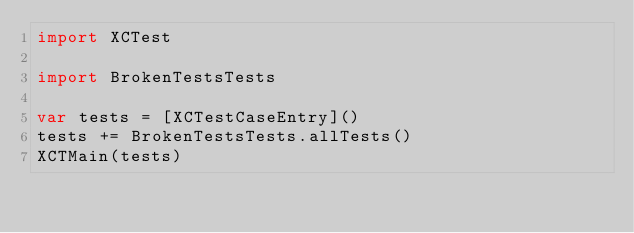Convert code to text. <code><loc_0><loc_0><loc_500><loc_500><_Swift_>import XCTest

import BrokenTestsTests

var tests = [XCTestCaseEntry]()
tests += BrokenTestsTests.allTests()
XCTMain(tests)
</code> 